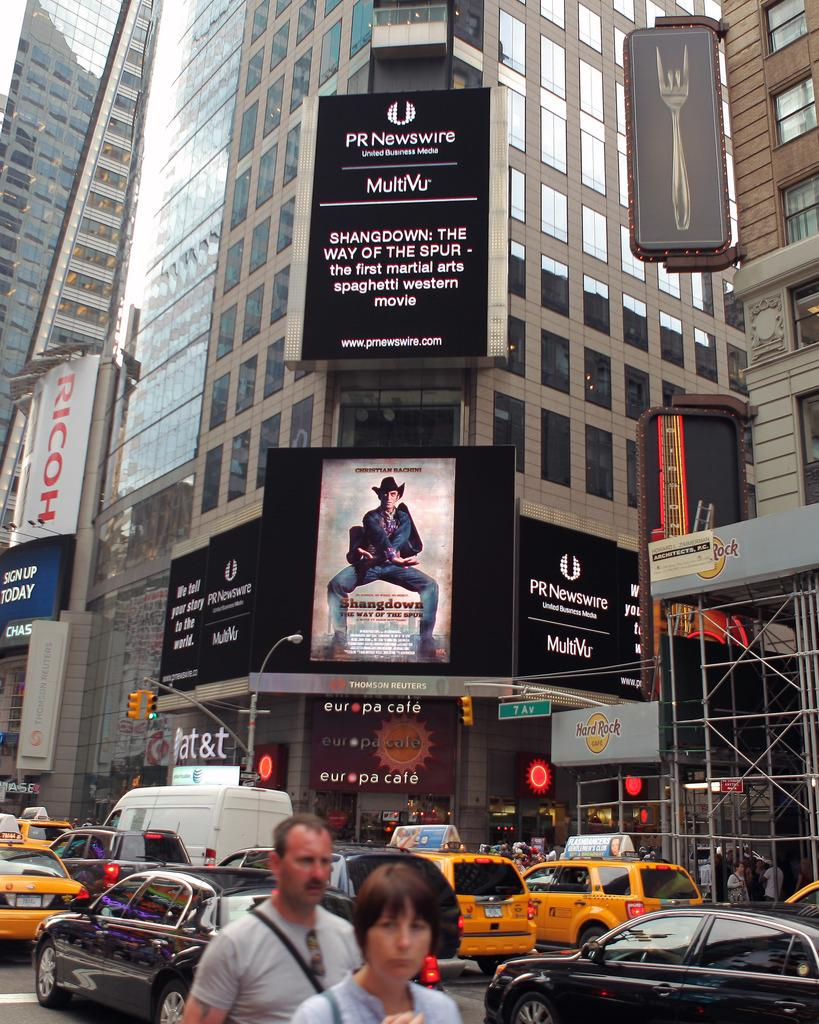<image>
Provide a brief description of the given image. A busy city street scene with the Europa cafe in the middle. 